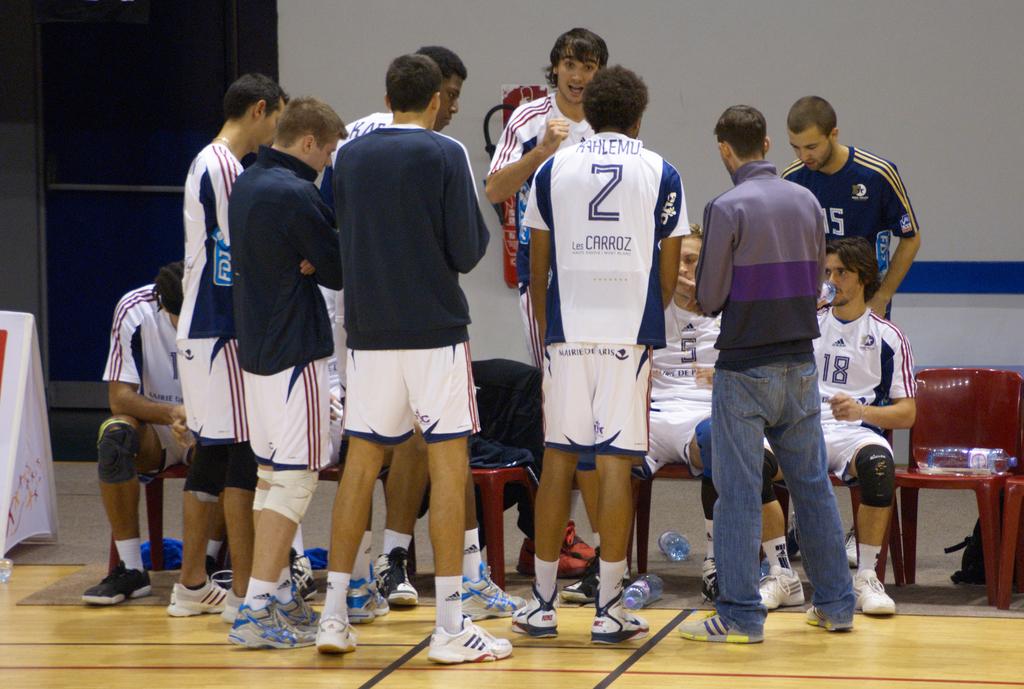What letter is displayed on the back of the jersey?
Your answer should be compact. Z. What is the number on the jersey of the man sitting on the very right?
Your answer should be compact. 18. 